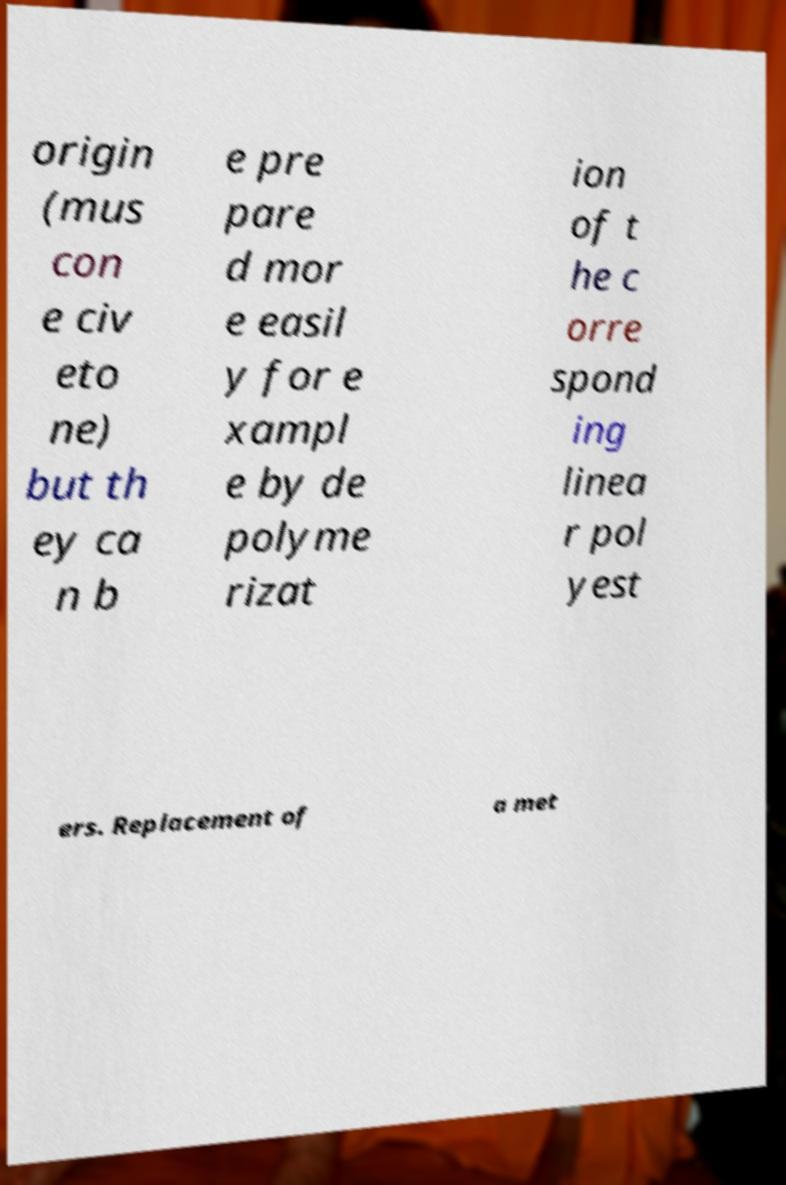Could you assist in decoding the text presented in this image and type it out clearly? origin (mus con e civ eto ne) but th ey ca n b e pre pare d mor e easil y for e xampl e by de polyme rizat ion of t he c orre spond ing linea r pol yest ers. Replacement of a met 